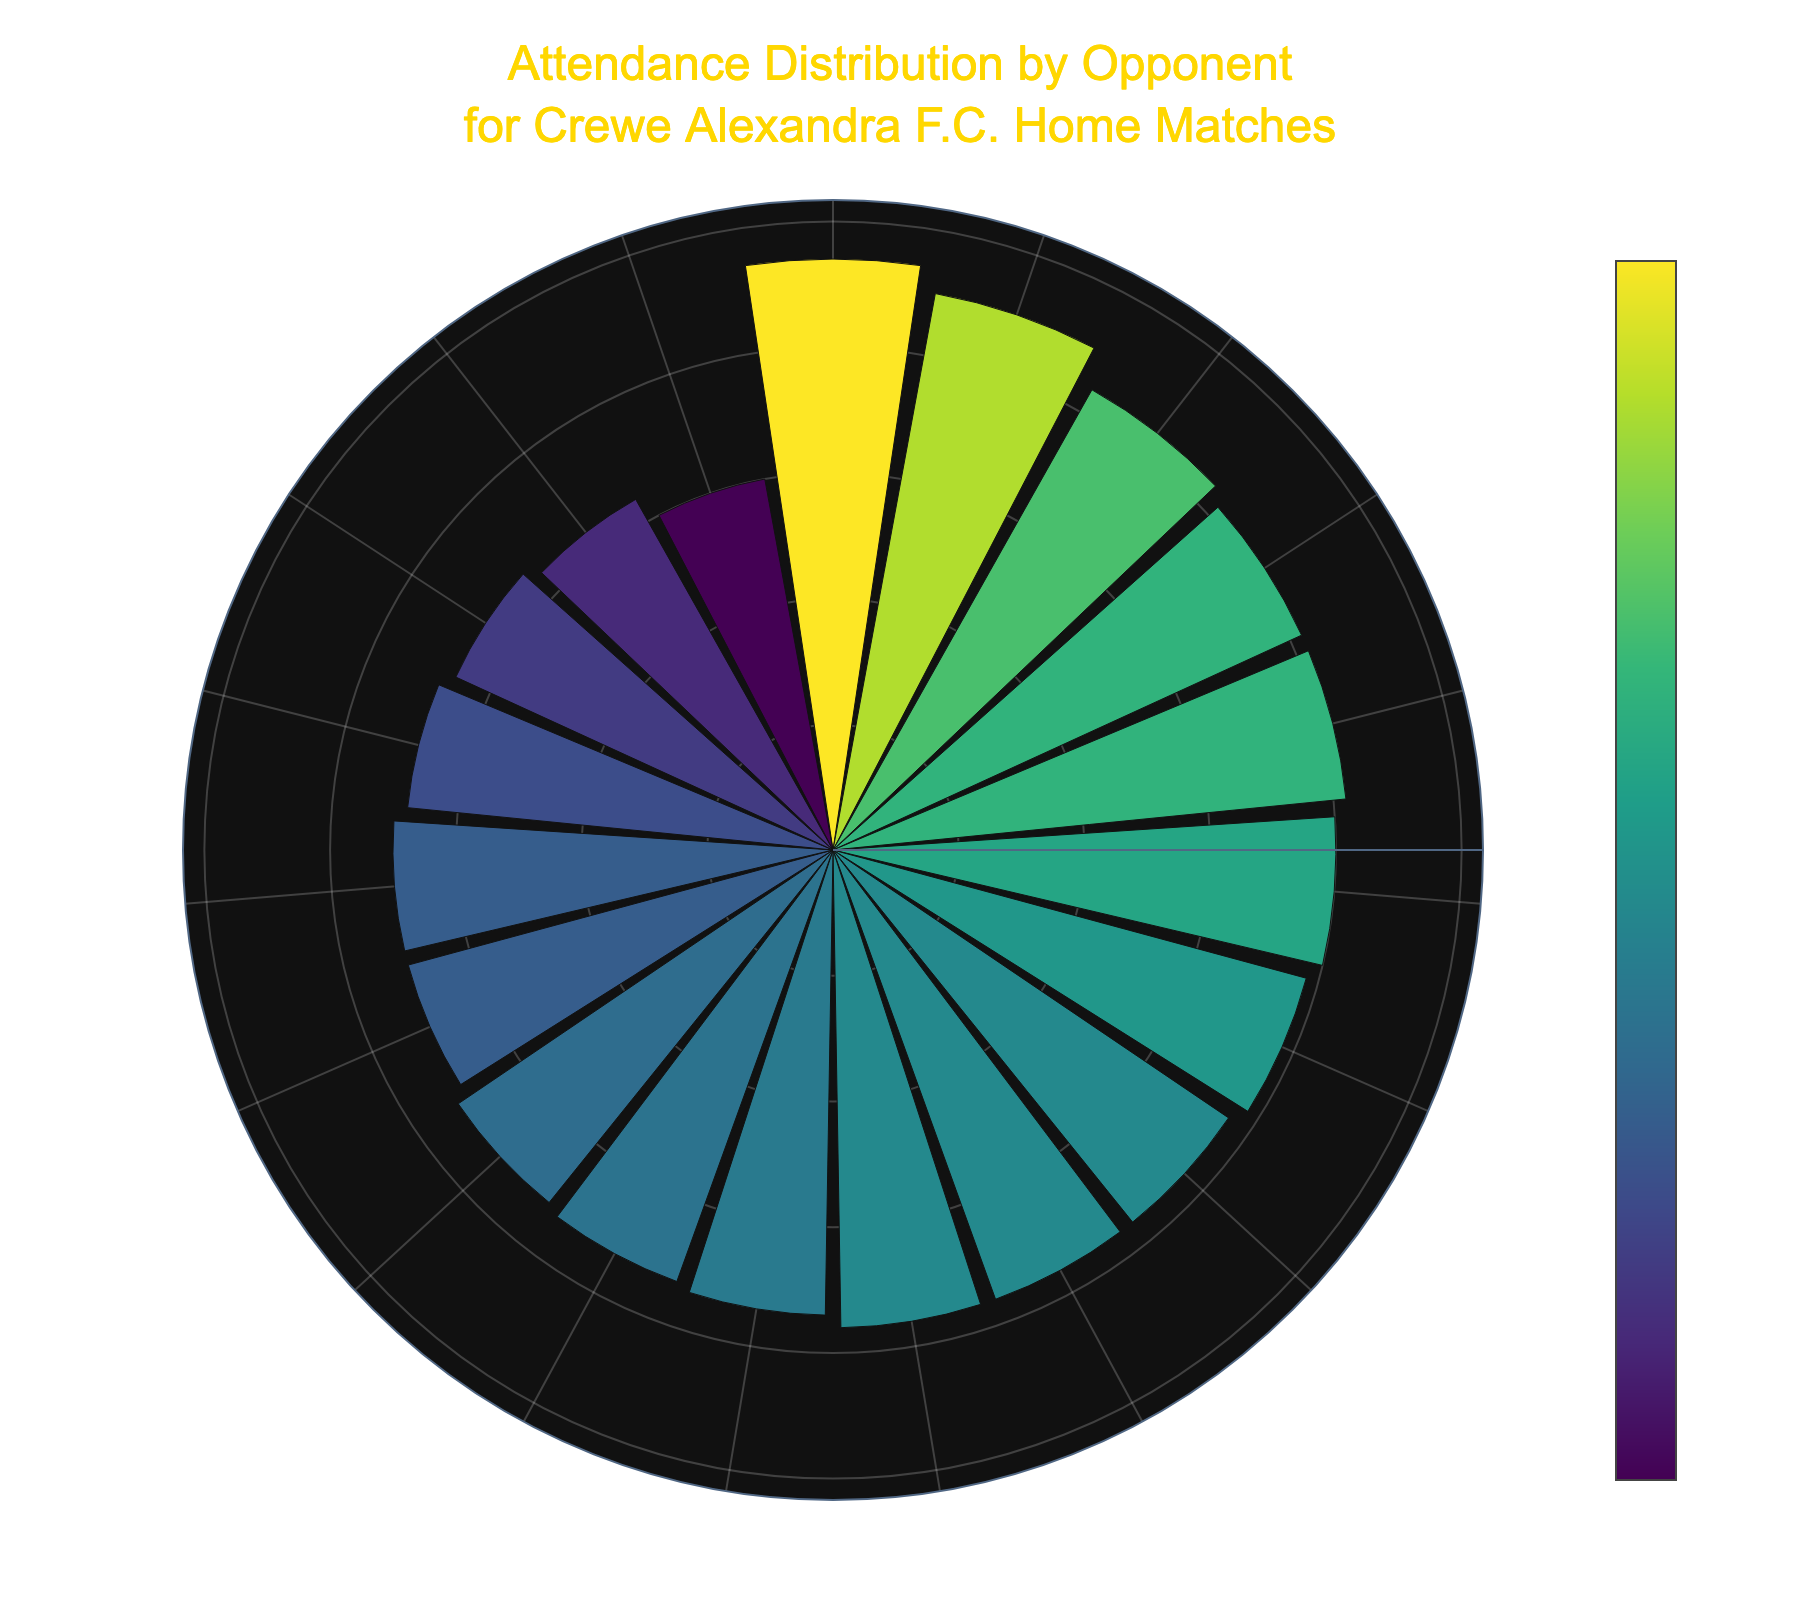What's the main title of the rose chart? The main title of the rose chart is displayed at the top and reads "Attendance Distribution by Opponent for Crewe Alexandra F.C. Home Matches". This can be seen in a larger and more prominent font compared to other texts.
Answer: Attendance Distribution by Opponent for Crewe Alexandra F.C. Home Matches Which opponent had the highest attendance? From the rose chart, look for the bar with the highest radial length. The bar corresponding to Bradford City has the highest attendance reading of 4700.
Answer: Bradford City What is the attendance range visualized on the radial axis? The radial axis range is determined by the visual markings and the maximum value shown on the graph. The maximum attendance value depicted is slightly more than 4500, around 4900 since it usually scales a little beyond the maximum actual value.
Answer: About 0 to 4900 How many opponents had an attendance greater than 4000? By inspecting the bars that extend beyond the 4000 mark, we can see that five opponents had an attendance greater than 4000: Tranmere Rovers, Port Vale, Bolton Wanderers, Northampton Town, and Bradford City.
Answer: Five Which opponent had the lowest attendance? From the chart, locate the shortest bar in the rose plot. Stevenage has the shortest bar with the lowest attendance of 3000.
Answer: Stevenage What is the average attendance across all opponents? To find the average attendance, sum all attendance figures: 4200 + 4100 + 3800 + 3900 + 4500 + 3700 + 3600 + 3500 + 4000 + 3800 + 3650 + 3400 + 3300 + 4100 + 4700 + 3200 + 3000 + 3500 + 3800 = 72250. Now, divide by the number of opponents, which is 19. The average attendance is 72250/19 ≈ 3803.
Answer: Approximately 3803 Which two opponents had the closest attendance figures? The bars for Colchester United (3400) and Cheltenham Town (3300) are very close in length, reflecting a small difference in their attendance numbers.
Answer: Colchester United and Cheltenham Town What color scale is used to represent the attendance? The color scale used in the plot is 'Viridis', which typically transitions from purple to yellow-green as values increase. This can be verified by the marker color settings and color scale gradient visible in the chart.
Answer: Viridis Compare the attendance figures of Bolton Wanderers and Oldham Athletic. Which is higher and by how much? Bolton Wanderers has an attendance of 4500, while Oldham Athletic has 3700. The difference is calculated as 4500 - 3700, which equals 800. Therefore, Bolton Wanderers has a higher attendance by 800.
Answer: Bolton Wanderers by 800 How does the attendance for Forest Green Rovers compare to that for Grimsby Town? Forest Green Rovers has an attendance of 3500, and Grimsby Town also has an attendance of 3500 according to the plot. Thus, both have equal attendance figures.
Answer: Equal 